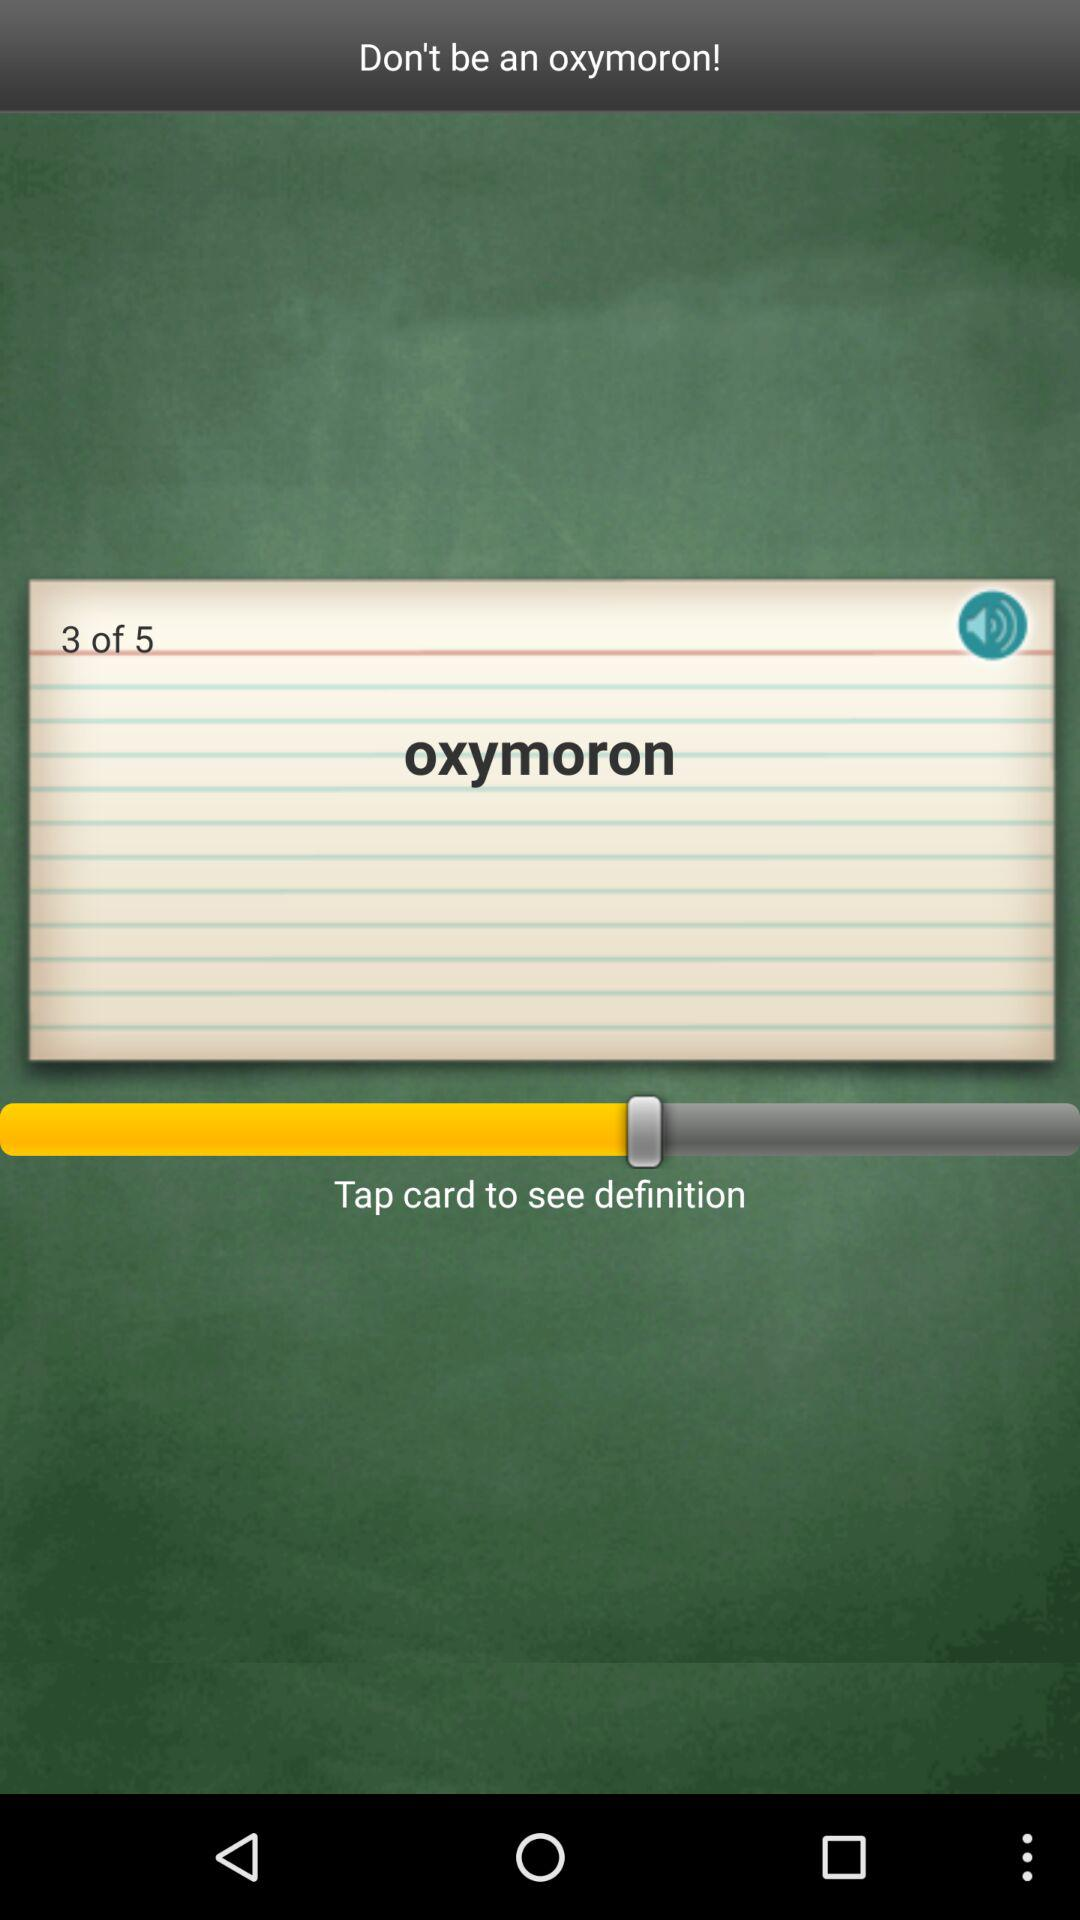What is the current page number? The current page number is 3. 